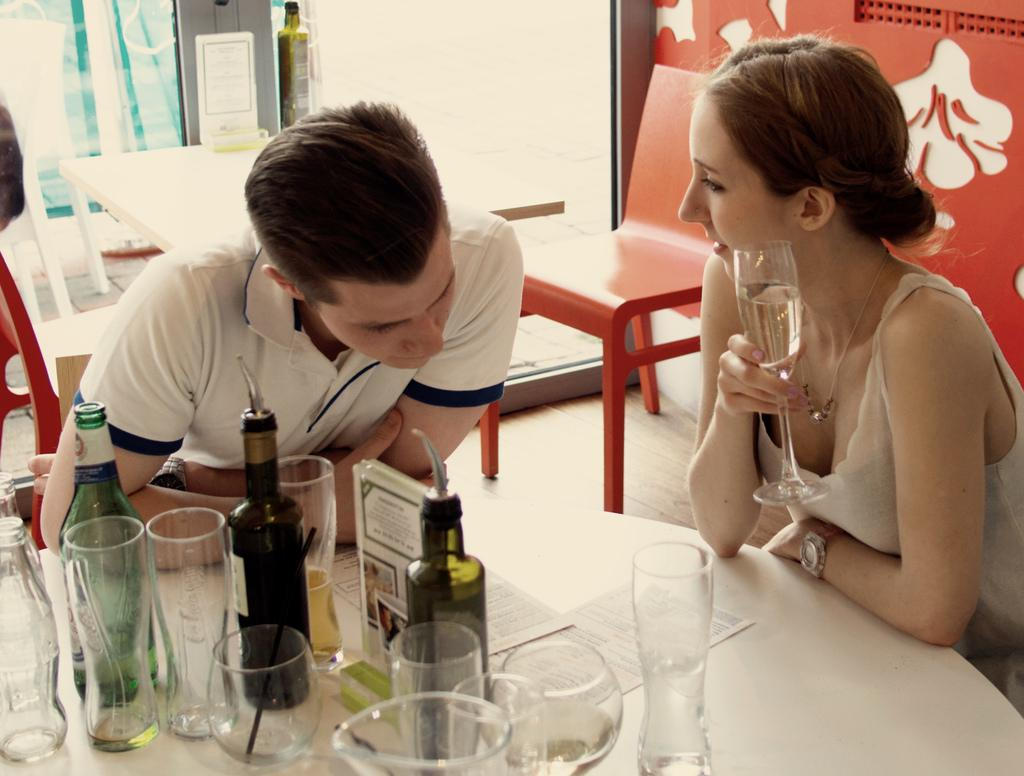How many people are present in the image? There are two people in the image, a woman and a man. What are the woman and man doing in the image? The woman and man are sitting around a table. What objects can be seen on the table? There are wine glasses, bottles, and papers on the table. What can be observed in the background of the image? There are tables and chairs in the background. What type of establishment might the setting be in? The setting appears to be in a restaurant. What type of steel is visible in the image? There is no steel present in the image. What time of day does the image depict? The image does not provide information about the time of day, but it is not specifically identified as an afternoon scene. 